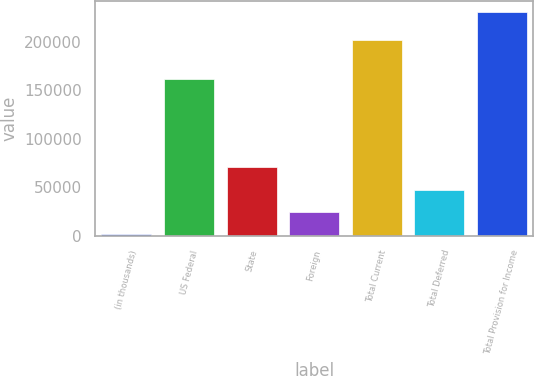Convert chart. <chart><loc_0><loc_0><loc_500><loc_500><bar_chart><fcel>(in thousands)<fcel>US Federal<fcel>State<fcel>Foreign<fcel>Total Current<fcel>Total Deferred<fcel>Total Provision for Income<nl><fcel>2019<fcel>161233<fcel>70583.4<fcel>24873.8<fcel>201926<fcel>47728.6<fcel>230567<nl></chart> 